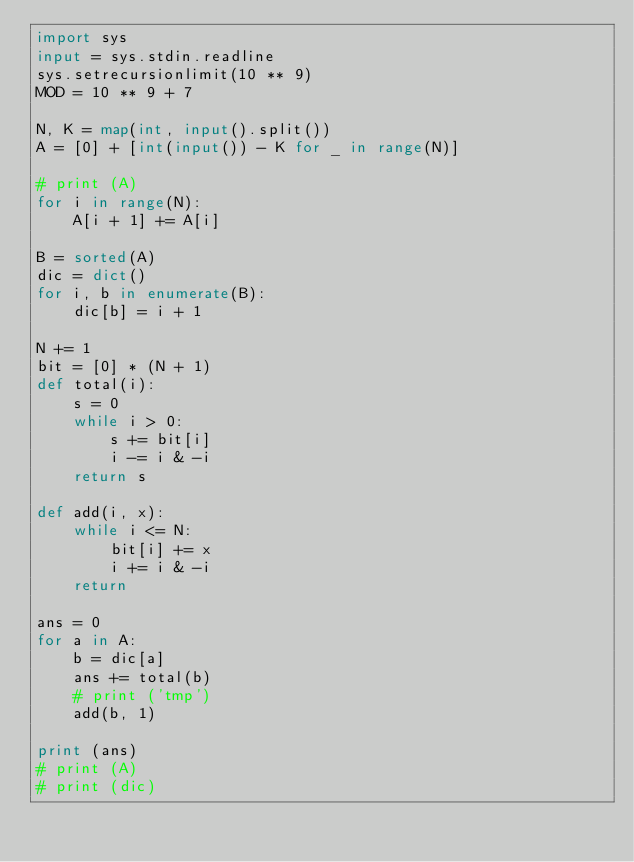Convert code to text. <code><loc_0><loc_0><loc_500><loc_500><_Python_>import sys
input = sys.stdin.readline
sys.setrecursionlimit(10 ** 9)
MOD = 10 ** 9 + 7

N, K = map(int, input().split())
A = [0] + [int(input()) - K for _ in range(N)]

# print (A)
for i in range(N):
    A[i + 1] += A[i]

B = sorted(A)
dic = dict()
for i, b in enumerate(B):
    dic[b] = i + 1

N += 1
bit = [0] * (N + 1)
def total(i):
    s = 0
    while i > 0:
        s += bit[i]
        i -= i & -i
    return s

def add(i, x):
    while i <= N:
        bit[i] += x
        i += i & -i
    return

ans = 0
for a in A:
    b = dic[a]
    ans += total(b)
    # print ('tmp')
    add(b, 1)

print (ans)
# print (A)
# print (dic)</code> 